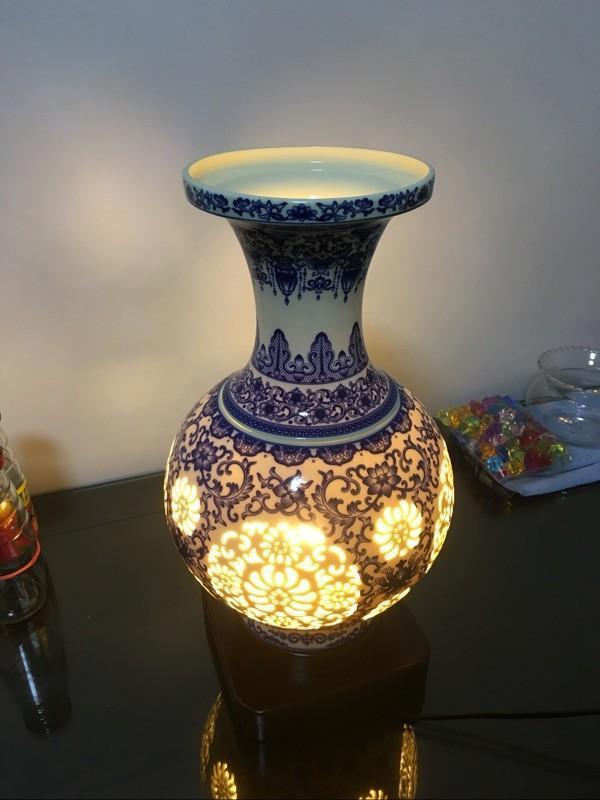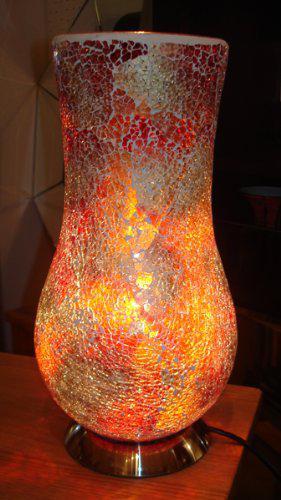The first image is the image on the left, the second image is the image on the right. Examine the images to the left and right. Is the description "One vase has a narrow neck, a footed base, and a circular design on the front, and it is seen head-on." accurate? Answer yes or no. No. 